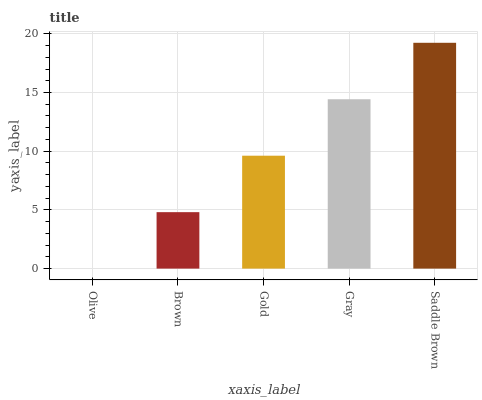Is Olive the minimum?
Answer yes or no. Yes. Is Saddle Brown the maximum?
Answer yes or no. Yes. Is Brown the minimum?
Answer yes or no. No. Is Brown the maximum?
Answer yes or no. No. Is Brown greater than Olive?
Answer yes or no. Yes. Is Olive less than Brown?
Answer yes or no. Yes. Is Olive greater than Brown?
Answer yes or no. No. Is Brown less than Olive?
Answer yes or no. No. Is Gold the high median?
Answer yes or no. Yes. Is Gold the low median?
Answer yes or no. Yes. Is Gray the high median?
Answer yes or no. No. Is Brown the low median?
Answer yes or no. No. 